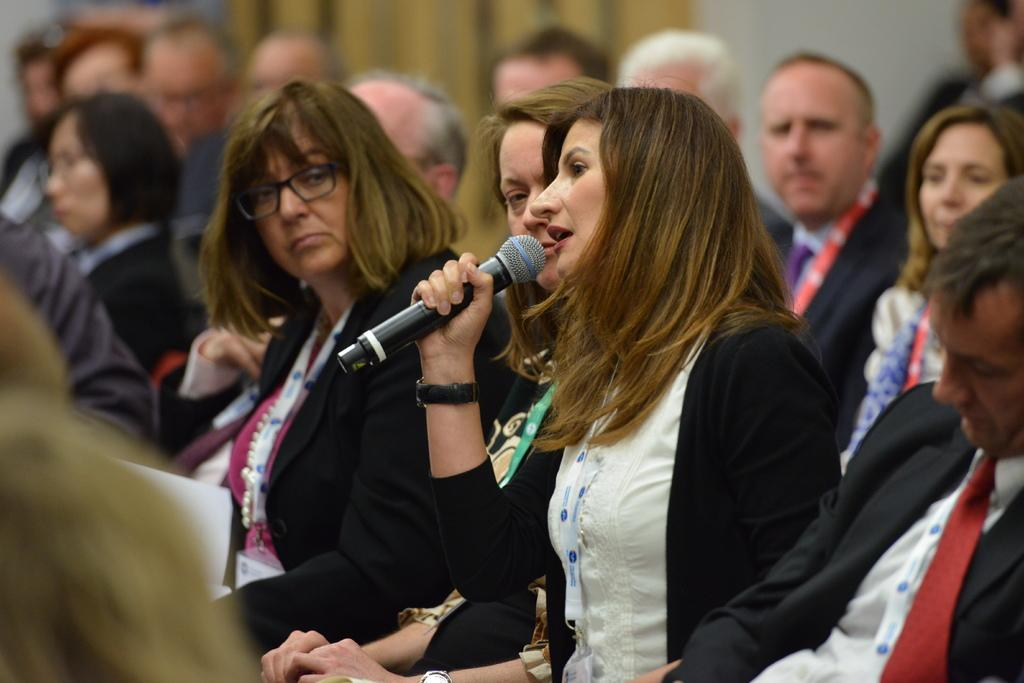What is the main subject of the image? The main subject of the image is a group of people. How are the people in the image positioned? The group of people are sitting on a chair. Can you describe one of the individuals in the image? There is a woman in a black jacket in the image. What is the woman doing in the image? The woman is holding a microphone. How is the woman in the black jacket differentiated from the others in the image? The woman is highlighted. What accessories is the woman wearing in the image? The woman is wearing spectacles and an ID card. What historical event is being reenacted by the group of people in the image? There is no indication of a historical event being reenacted in the image. What type of sticks are being used by the group of people in the image? There are no sticks visible in the image. 